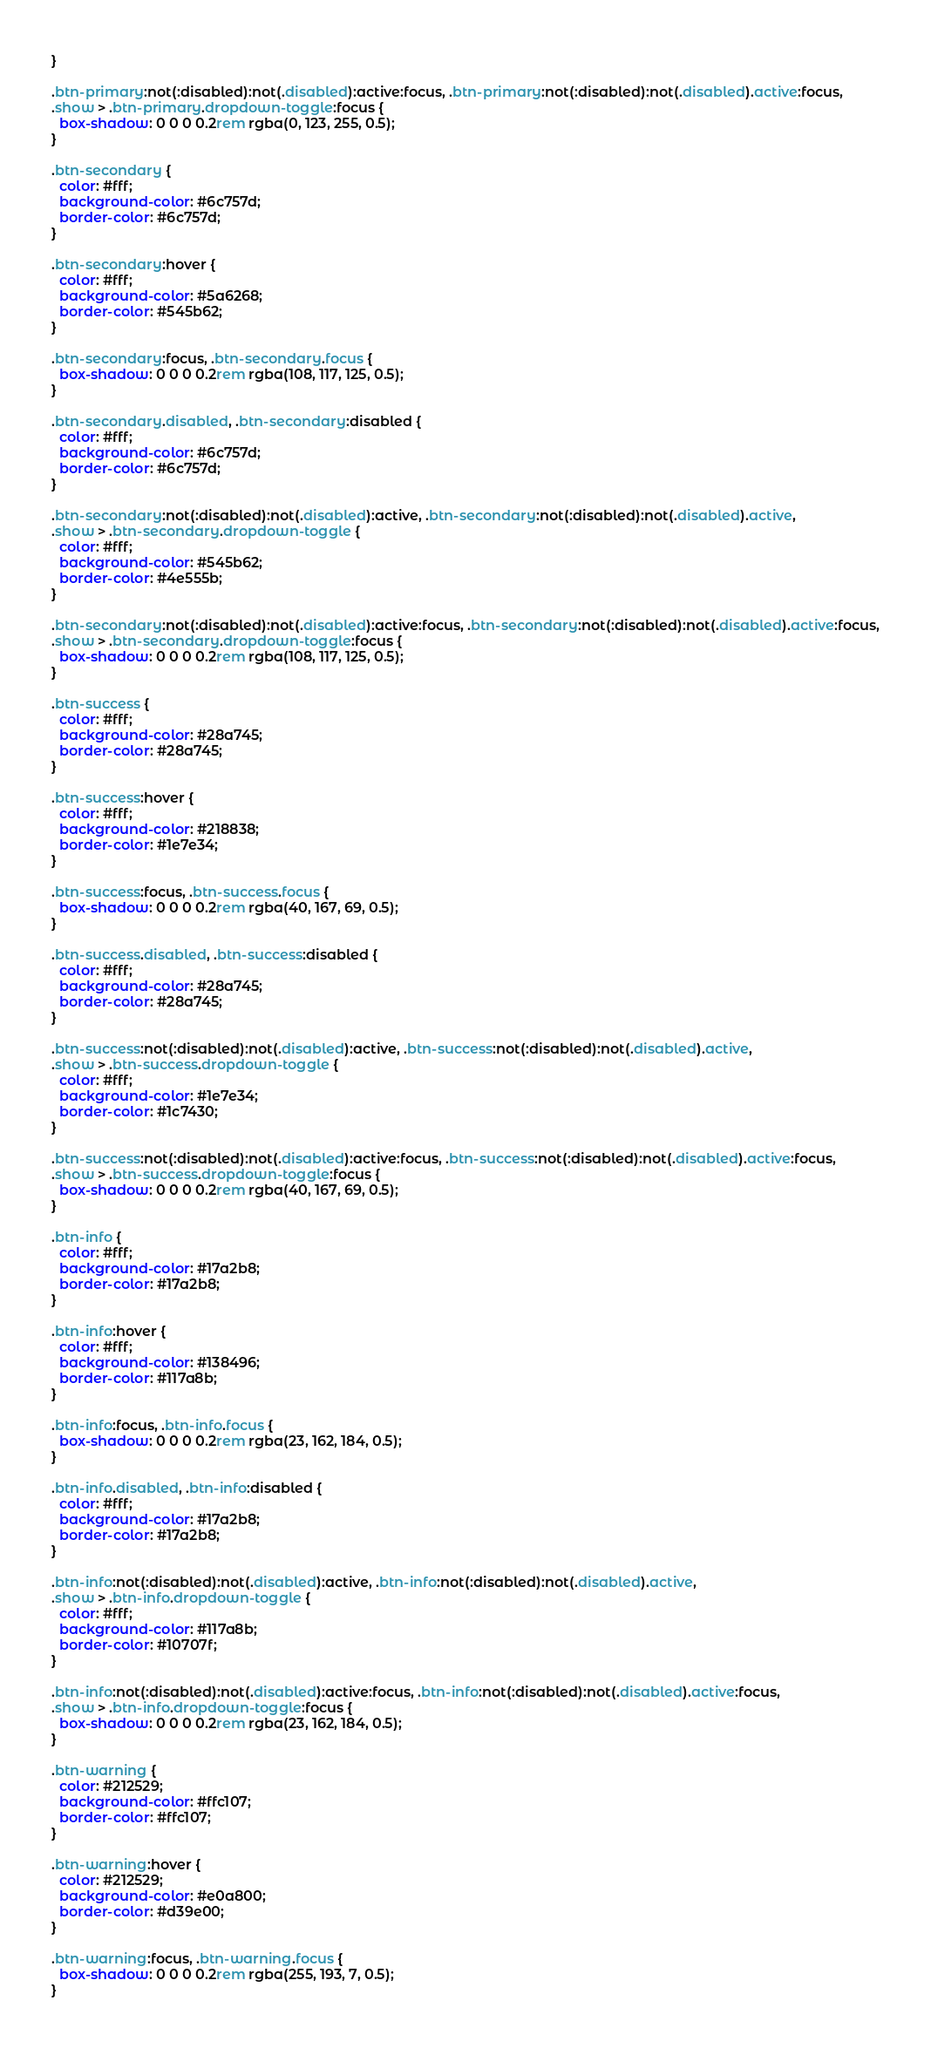Convert code to text. <code><loc_0><loc_0><loc_500><loc_500><_CSS_>}

.btn-primary:not(:disabled):not(.disabled):active:focus, .btn-primary:not(:disabled):not(.disabled).active:focus,
.show > .btn-primary.dropdown-toggle:focus {
  box-shadow: 0 0 0 0.2rem rgba(0, 123, 255, 0.5);
}

.btn-secondary {
  color: #fff;
  background-color: #6c757d;
  border-color: #6c757d;
}

.btn-secondary:hover {
  color: #fff;
  background-color: #5a6268;
  border-color: #545b62;
}

.btn-secondary:focus, .btn-secondary.focus {
  box-shadow: 0 0 0 0.2rem rgba(108, 117, 125, 0.5);
}

.btn-secondary.disabled, .btn-secondary:disabled {
  color: #fff;
  background-color: #6c757d;
  border-color: #6c757d;
}

.btn-secondary:not(:disabled):not(.disabled):active, .btn-secondary:not(:disabled):not(.disabled).active,
.show > .btn-secondary.dropdown-toggle {
  color: #fff;
  background-color: #545b62;
  border-color: #4e555b;
}

.btn-secondary:not(:disabled):not(.disabled):active:focus, .btn-secondary:not(:disabled):not(.disabled).active:focus,
.show > .btn-secondary.dropdown-toggle:focus {
  box-shadow: 0 0 0 0.2rem rgba(108, 117, 125, 0.5);
}

.btn-success {
  color: #fff;
  background-color: #28a745;
  border-color: #28a745;
}

.btn-success:hover {
  color: #fff;
  background-color: #218838;
  border-color: #1e7e34;
}

.btn-success:focus, .btn-success.focus {
  box-shadow: 0 0 0 0.2rem rgba(40, 167, 69, 0.5);
}

.btn-success.disabled, .btn-success:disabled {
  color: #fff;
  background-color: #28a745;
  border-color: #28a745;
}

.btn-success:not(:disabled):not(.disabled):active, .btn-success:not(:disabled):not(.disabled).active,
.show > .btn-success.dropdown-toggle {
  color: #fff;
  background-color: #1e7e34;
  border-color: #1c7430;
}

.btn-success:not(:disabled):not(.disabled):active:focus, .btn-success:not(:disabled):not(.disabled).active:focus,
.show > .btn-success.dropdown-toggle:focus {
  box-shadow: 0 0 0 0.2rem rgba(40, 167, 69, 0.5);
}

.btn-info {
  color: #fff;
  background-color: #17a2b8;
  border-color: #17a2b8;
}

.btn-info:hover {
  color: #fff;
  background-color: #138496;
  border-color: #117a8b;
}

.btn-info:focus, .btn-info.focus {
  box-shadow: 0 0 0 0.2rem rgba(23, 162, 184, 0.5);
}

.btn-info.disabled, .btn-info:disabled {
  color: #fff;
  background-color: #17a2b8;
  border-color: #17a2b8;
}

.btn-info:not(:disabled):not(.disabled):active, .btn-info:not(:disabled):not(.disabled).active,
.show > .btn-info.dropdown-toggle {
  color: #fff;
  background-color: #117a8b;
  border-color: #10707f;
}

.btn-info:not(:disabled):not(.disabled):active:focus, .btn-info:not(:disabled):not(.disabled).active:focus,
.show > .btn-info.dropdown-toggle:focus {
  box-shadow: 0 0 0 0.2rem rgba(23, 162, 184, 0.5);
}

.btn-warning {
  color: #212529;
  background-color: #ffc107;
  border-color: #ffc107;
}

.btn-warning:hover {
  color: #212529;
  background-color: #e0a800;
  border-color: #d39e00;
}

.btn-warning:focus, .btn-warning.focus {
  box-shadow: 0 0 0 0.2rem rgba(255, 193, 7, 0.5);
}
</code> 